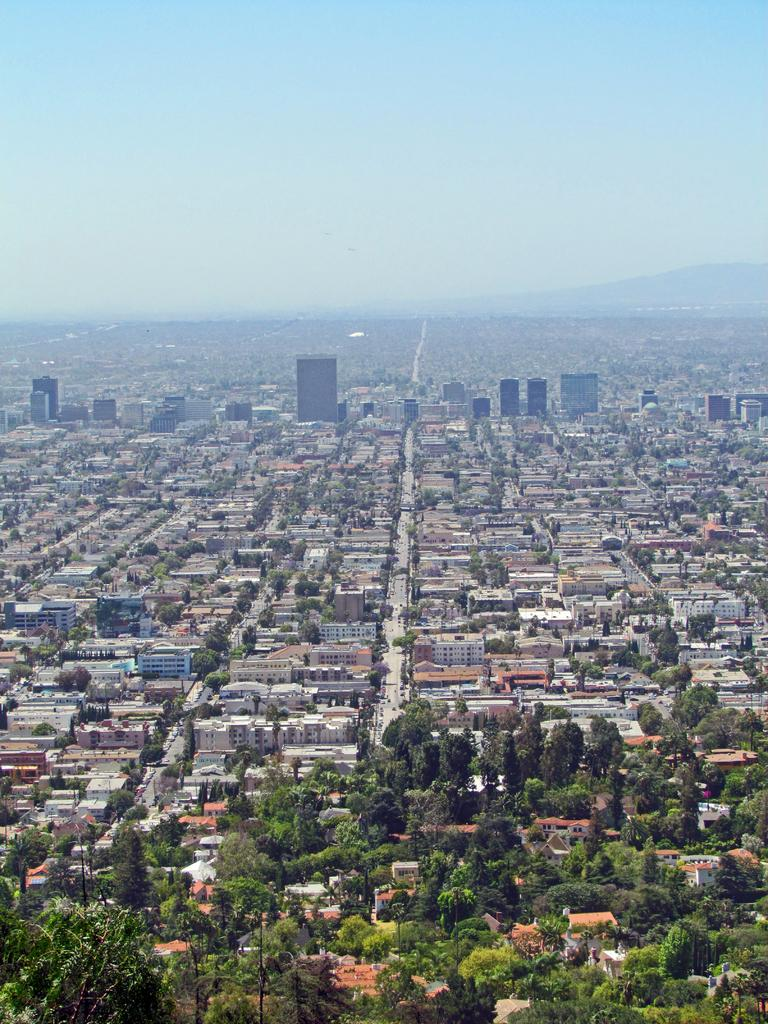What type of natural elements can be seen in the image? There are trees in the image. What type of man-made structures are visible in the image? There are buildings in the image. What type of transportation can be seen on the ground in the image? There are vehicles on the ground in the image. What type of geographical features can be seen in the background of the image? There are mountains in the background of the image. What type of atmospheric conditions can be seen in the sky in the image? There are clouds in the sky in the image. What type of wrench is being used to wash the trains in the image? There are no trains or wrenches present in the image. What type of wash is being used to clean the vehicles in the image? The image does not show any washing or cleaning of vehicles; it only shows them on the ground. 